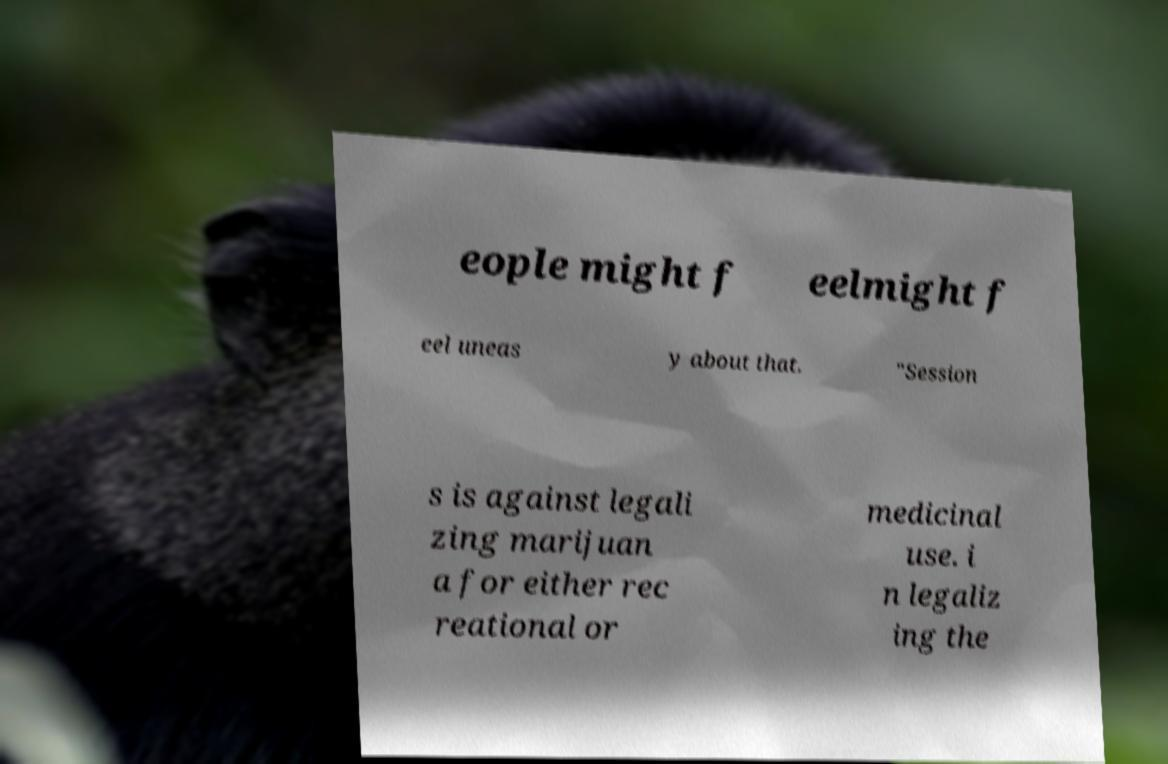Please identify and transcribe the text found in this image. eople might f eelmight f eel uneas y about that. "Session s is against legali zing marijuan a for either rec reational or medicinal use. i n legaliz ing the 